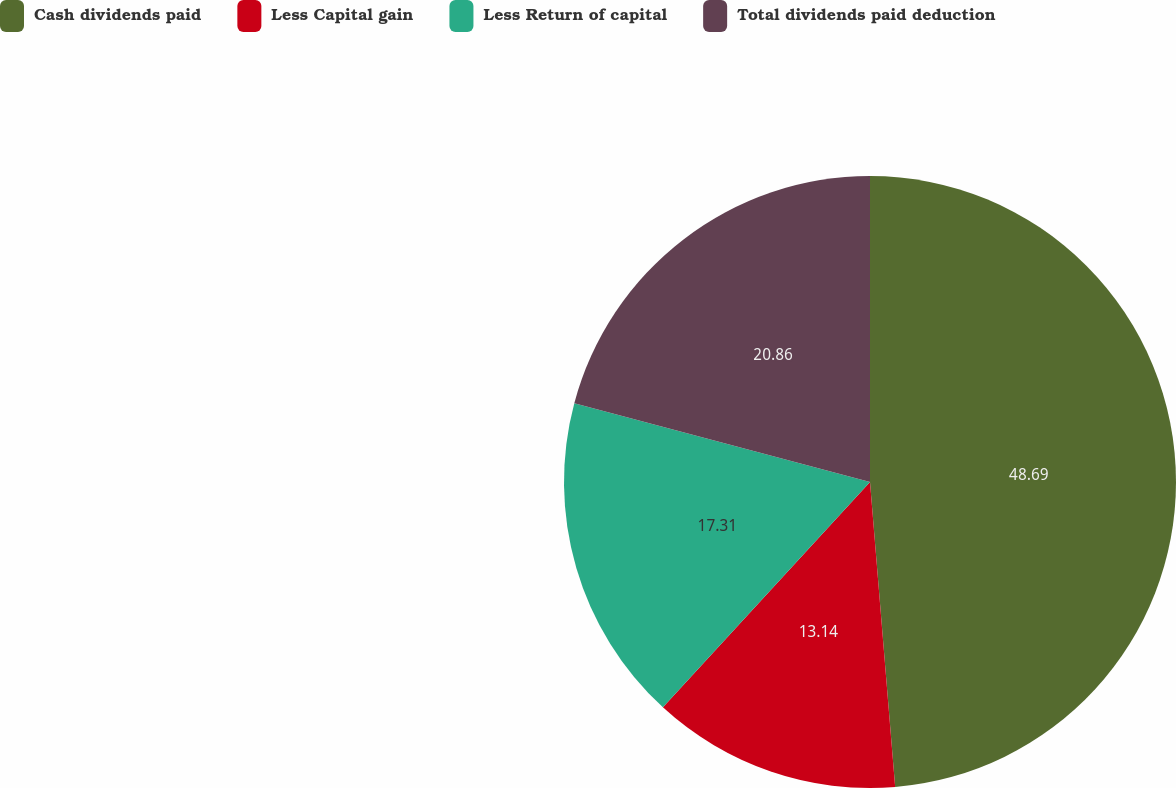Convert chart to OTSL. <chart><loc_0><loc_0><loc_500><loc_500><pie_chart><fcel>Cash dividends paid<fcel>Less Capital gain<fcel>Less Return of capital<fcel>Total dividends paid deduction<nl><fcel>48.69%<fcel>13.14%<fcel>17.31%<fcel>20.86%<nl></chart> 